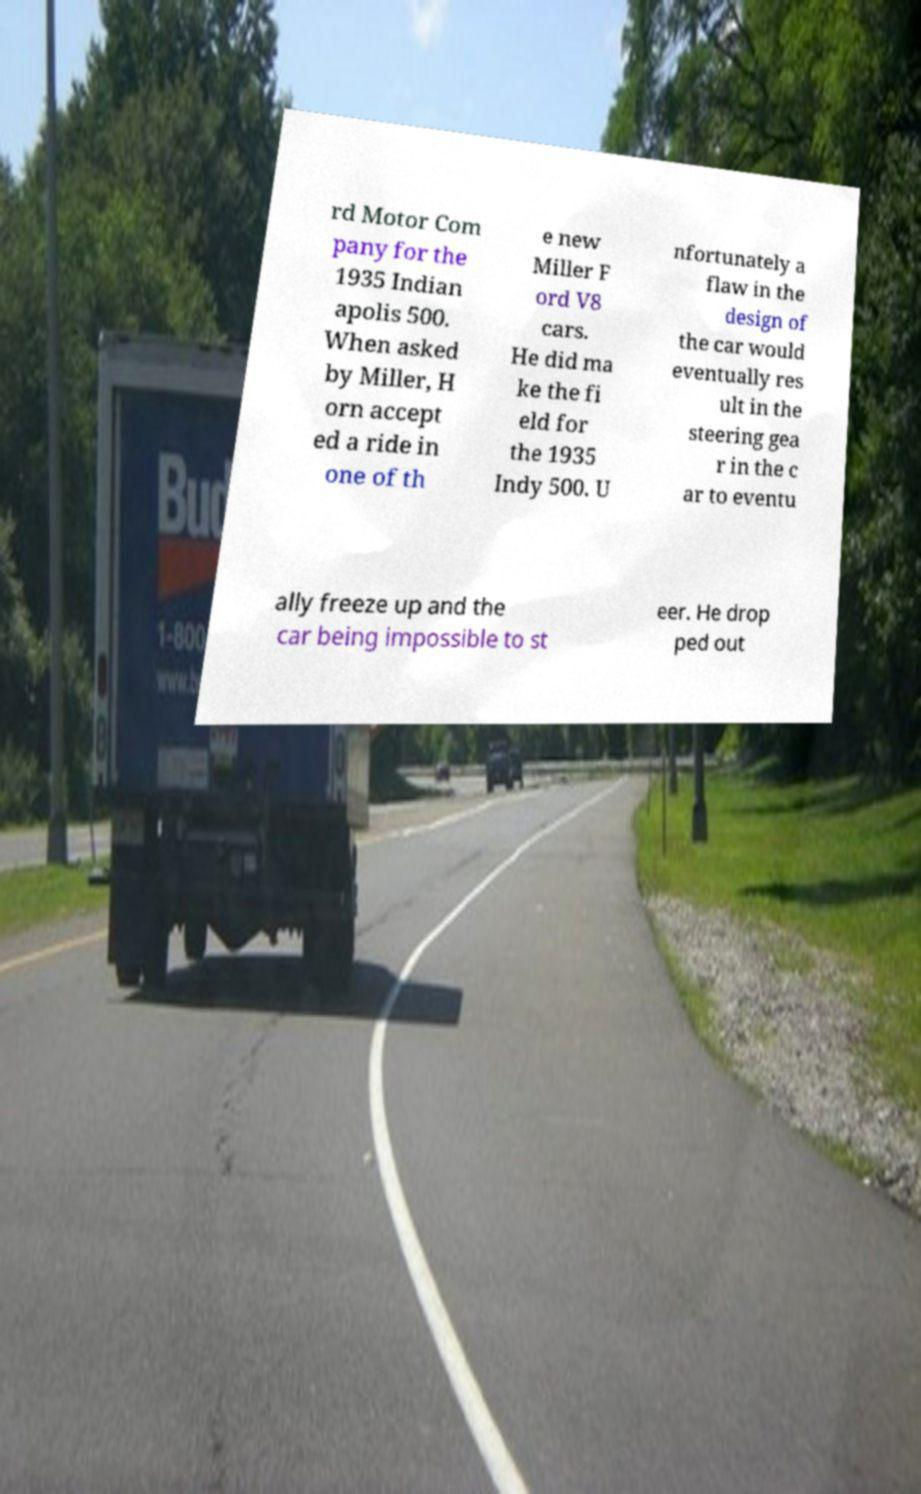What messages or text are displayed in this image? I need them in a readable, typed format. rd Motor Com pany for the 1935 Indian apolis 500. When asked by Miller, H orn accept ed a ride in one of th e new Miller F ord V8 cars. He did ma ke the fi eld for the 1935 Indy 500. U nfortunately a flaw in the design of the car would eventually res ult in the steering gea r in the c ar to eventu ally freeze up and the car being impossible to st eer. He drop ped out 